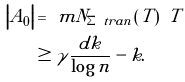Convert formula to latex. <formula><loc_0><loc_0><loc_500><loc_500>\left | A _ { 0 } \right | & = \ m N _ { \Sigma ^ { \ } t r a n } \left ( T \right ) \ T \\ & \geq \gamma \frac { d k } { \log n } - k .</formula> 